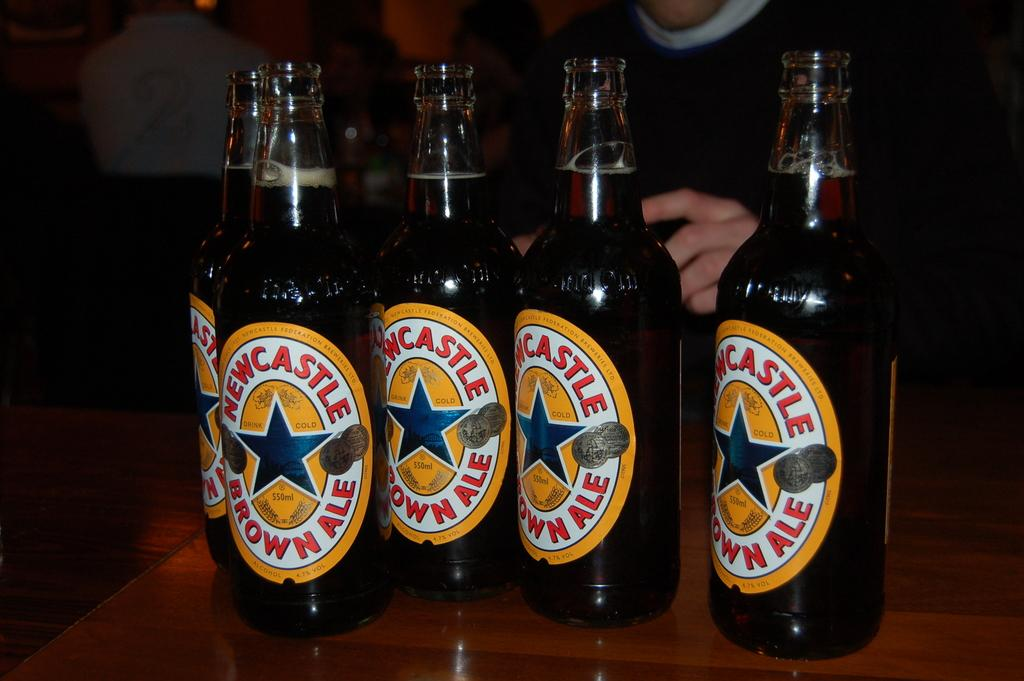<image>
Create a compact narrative representing the image presented. Five bottles of beer that say Newcastle Brown Ale. 